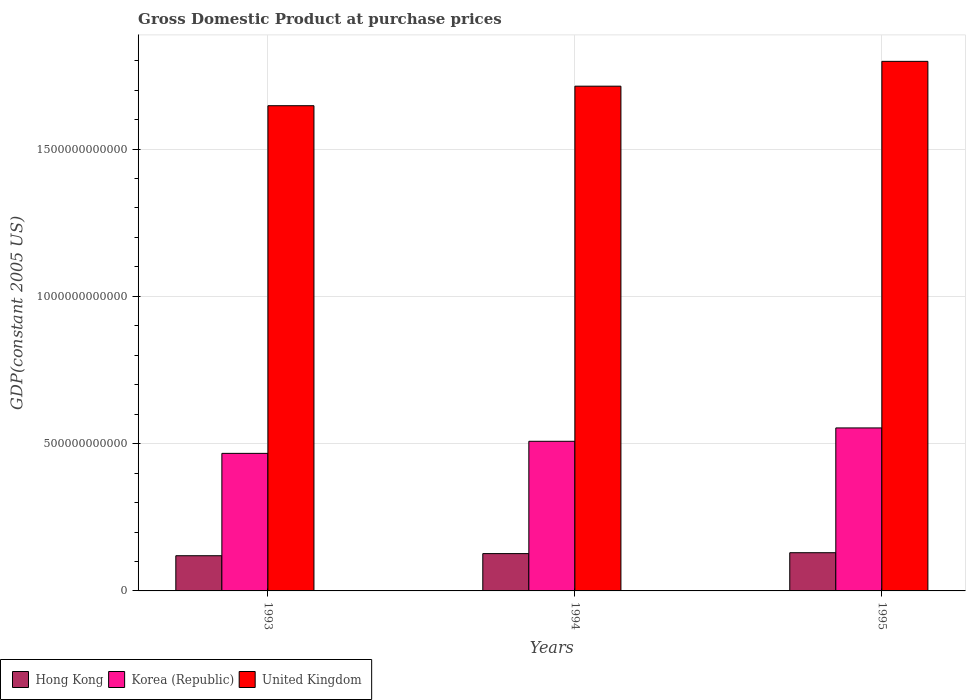How many different coloured bars are there?
Ensure brevity in your answer.  3. How many bars are there on the 1st tick from the left?
Ensure brevity in your answer.  3. How many bars are there on the 1st tick from the right?
Give a very brief answer. 3. What is the label of the 3rd group of bars from the left?
Provide a short and direct response. 1995. What is the GDP at purchase prices in United Kingdom in 1993?
Your answer should be compact. 1.65e+12. Across all years, what is the maximum GDP at purchase prices in United Kingdom?
Give a very brief answer. 1.80e+12. Across all years, what is the minimum GDP at purchase prices in United Kingdom?
Offer a very short reply. 1.65e+12. What is the total GDP at purchase prices in United Kingdom in the graph?
Your answer should be compact. 5.16e+12. What is the difference between the GDP at purchase prices in United Kingdom in 1994 and that in 1995?
Your answer should be compact. -8.43e+1. What is the difference between the GDP at purchase prices in United Kingdom in 1993 and the GDP at purchase prices in Korea (Republic) in 1995?
Offer a terse response. 1.09e+12. What is the average GDP at purchase prices in Hong Kong per year?
Provide a succinct answer. 1.25e+11. In the year 1995, what is the difference between the GDP at purchase prices in Hong Kong and GDP at purchase prices in Korea (Republic)?
Ensure brevity in your answer.  -4.24e+11. What is the ratio of the GDP at purchase prices in Korea (Republic) in 1994 to that in 1995?
Your answer should be very brief. 0.92. Is the GDP at purchase prices in Korea (Republic) in 1994 less than that in 1995?
Make the answer very short. Yes. What is the difference between the highest and the second highest GDP at purchase prices in United Kingdom?
Make the answer very short. 8.43e+1. What is the difference between the highest and the lowest GDP at purchase prices in Hong Kong?
Offer a very short reply. 1.02e+1. What does the 2nd bar from the left in 1995 represents?
Your answer should be compact. Korea (Republic). Is it the case that in every year, the sum of the GDP at purchase prices in United Kingdom and GDP at purchase prices in Hong Kong is greater than the GDP at purchase prices in Korea (Republic)?
Give a very brief answer. Yes. How many bars are there?
Give a very brief answer. 9. How many years are there in the graph?
Your answer should be very brief. 3. What is the difference between two consecutive major ticks on the Y-axis?
Your answer should be compact. 5.00e+11. Does the graph contain any zero values?
Give a very brief answer. No. Does the graph contain grids?
Offer a very short reply. Yes. Where does the legend appear in the graph?
Your answer should be compact. Bottom left. How many legend labels are there?
Provide a short and direct response. 3. How are the legend labels stacked?
Provide a succinct answer. Horizontal. What is the title of the graph?
Your answer should be very brief. Gross Domestic Product at purchase prices. Does "Cameroon" appear as one of the legend labels in the graph?
Offer a very short reply. No. What is the label or title of the Y-axis?
Your answer should be very brief. GDP(constant 2005 US). What is the GDP(constant 2005 US) in Hong Kong in 1993?
Make the answer very short. 1.20e+11. What is the GDP(constant 2005 US) in Korea (Republic) in 1993?
Make the answer very short. 4.67e+11. What is the GDP(constant 2005 US) in United Kingdom in 1993?
Your response must be concise. 1.65e+12. What is the GDP(constant 2005 US) in Hong Kong in 1994?
Offer a very short reply. 1.27e+11. What is the GDP(constant 2005 US) of Korea (Republic) in 1994?
Offer a very short reply. 5.08e+11. What is the GDP(constant 2005 US) in United Kingdom in 1994?
Your answer should be compact. 1.71e+12. What is the GDP(constant 2005 US) of Hong Kong in 1995?
Your answer should be compact. 1.30e+11. What is the GDP(constant 2005 US) in Korea (Republic) in 1995?
Give a very brief answer. 5.53e+11. What is the GDP(constant 2005 US) in United Kingdom in 1995?
Provide a succinct answer. 1.80e+12. Across all years, what is the maximum GDP(constant 2005 US) in Hong Kong?
Keep it short and to the point. 1.30e+11. Across all years, what is the maximum GDP(constant 2005 US) in Korea (Republic)?
Provide a succinct answer. 5.53e+11. Across all years, what is the maximum GDP(constant 2005 US) of United Kingdom?
Offer a very short reply. 1.80e+12. Across all years, what is the minimum GDP(constant 2005 US) in Hong Kong?
Make the answer very short. 1.20e+11. Across all years, what is the minimum GDP(constant 2005 US) of Korea (Republic)?
Ensure brevity in your answer.  4.67e+11. Across all years, what is the minimum GDP(constant 2005 US) of United Kingdom?
Offer a very short reply. 1.65e+12. What is the total GDP(constant 2005 US) of Hong Kong in the graph?
Make the answer very short. 3.76e+11. What is the total GDP(constant 2005 US) of Korea (Republic) in the graph?
Provide a succinct answer. 1.53e+12. What is the total GDP(constant 2005 US) of United Kingdom in the graph?
Ensure brevity in your answer.  5.16e+12. What is the difference between the GDP(constant 2005 US) in Hong Kong in 1993 and that in 1994?
Provide a succinct answer. -7.21e+09. What is the difference between the GDP(constant 2005 US) of Korea (Republic) in 1993 and that in 1994?
Your response must be concise. -4.10e+1. What is the difference between the GDP(constant 2005 US) in United Kingdom in 1993 and that in 1994?
Make the answer very short. -6.63e+1. What is the difference between the GDP(constant 2005 US) in Hong Kong in 1993 and that in 1995?
Your response must be concise. -1.02e+1. What is the difference between the GDP(constant 2005 US) of Korea (Republic) in 1993 and that in 1995?
Your answer should be compact. -8.63e+1. What is the difference between the GDP(constant 2005 US) in United Kingdom in 1993 and that in 1995?
Provide a short and direct response. -1.51e+11. What is the difference between the GDP(constant 2005 US) of Hong Kong in 1994 and that in 1995?
Offer a very short reply. -3.01e+09. What is the difference between the GDP(constant 2005 US) of Korea (Republic) in 1994 and that in 1995?
Make the answer very short. -4.54e+1. What is the difference between the GDP(constant 2005 US) in United Kingdom in 1994 and that in 1995?
Your answer should be very brief. -8.43e+1. What is the difference between the GDP(constant 2005 US) in Hong Kong in 1993 and the GDP(constant 2005 US) in Korea (Republic) in 1994?
Make the answer very short. -3.88e+11. What is the difference between the GDP(constant 2005 US) in Hong Kong in 1993 and the GDP(constant 2005 US) in United Kingdom in 1994?
Your answer should be compact. -1.59e+12. What is the difference between the GDP(constant 2005 US) in Korea (Republic) in 1993 and the GDP(constant 2005 US) in United Kingdom in 1994?
Provide a succinct answer. -1.25e+12. What is the difference between the GDP(constant 2005 US) of Hong Kong in 1993 and the GDP(constant 2005 US) of Korea (Republic) in 1995?
Offer a very short reply. -4.34e+11. What is the difference between the GDP(constant 2005 US) in Hong Kong in 1993 and the GDP(constant 2005 US) in United Kingdom in 1995?
Provide a short and direct response. -1.68e+12. What is the difference between the GDP(constant 2005 US) of Korea (Republic) in 1993 and the GDP(constant 2005 US) of United Kingdom in 1995?
Offer a very short reply. -1.33e+12. What is the difference between the GDP(constant 2005 US) of Hong Kong in 1994 and the GDP(constant 2005 US) of Korea (Republic) in 1995?
Provide a short and direct response. -4.27e+11. What is the difference between the GDP(constant 2005 US) in Hong Kong in 1994 and the GDP(constant 2005 US) in United Kingdom in 1995?
Offer a terse response. -1.67e+12. What is the difference between the GDP(constant 2005 US) in Korea (Republic) in 1994 and the GDP(constant 2005 US) in United Kingdom in 1995?
Give a very brief answer. -1.29e+12. What is the average GDP(constant 2005 US) of Hong Kong per year?
Provide a short and direct response. 1.25e+11. What is the average GDP(constant 2005 US) in Korea (Republic) per year?
Ensure brevity in your answer.  5.09e+11. What is the average GDP(constant 2005 US) of United Kingdom per year?
Make the answer very short. 1.72e+12. In the year 1993, what is the difference between the GDP(constant 2005 US) in Hong Kong and GDP(constant 2005 US) in Korea (Republic)?
Provide a succinct answer. -3.47e+11. In the year 1993, what is the difference between the GDP(constant 2005 US) in Hong Kong and GDP(constant 2005 US) in United Kingdom?
Provide a succinct answer. -1.53e+12. In the year 1993, what is the difference between the GDP(constant 2005 US) in Korea (Republic) and GDP(constant 2005 US) in United Kingdom?
Your response must be concise. -1.18e+12. In the year 1994, what is the difference between the GDP(constant 2005 US) of Hong Kong and GDP(constant 2005 US) of Korea (Republic)?
Make the answer very short. -3.81e+11. In the year 1994, what is the difference between the GDP(constant 2005 US) of Hong Kong and GDP(constant 2005 US) of United Kingdom?
Ensure brevity in your answer.  -1.59e+12. In the year 1994, what is the difference between the GDP(constant 2005 US) in Korea (Republic) and GDP(constant 2005 US) in United Kingdom?
Provide a short and direct response. -1.21e+12. In the year 1995, what is the difference between the GDP(constant 2005 US) in Hong Kong and GDP(constant 2005 US) in Korea (Republic)?
Provide a short and direct response. -4.24e+11. In the year 1995, what is the difference between the GDP(constant 2005 US) of Hong Kong and GDP(constant 2005 US) of United Kingdom?
Provide a succinct answer. -1.67e+12. In the year 1995, what is the difference between the GDP(constant 2005 US) in Korea (Republic) and GDP(constant 2005 US) in United Kingdom?
Your answer should be very brief. -1.24e+12. What is the ratio of the GDP(constant 2005 US) in Hong Kong in 1993 to that in 1994?
Your answer should be compact. 0.94. What is the ratio of the GDP(constant 2005 US) in Korea (Republic) in 1993 to that in 1994?
Your response must be concise. 0.92. What is the ratio of the GDP(constant 2005 US) of United Kingdom in 1993 to that in 1994?
Offer a very short reply. 0.96. What is the ratio of the GDP(constant 2005 US) in Hong Kong in 1993 to that in 1995?
Make the answer very short. 0.92. What is the ratio of the GDP(constant 2005 US) of Korea (Republic) in 1993 to that in 1995?
Provide a short and direct response. 0.84. What is the ratio of the GDP(constant 2005 US) of United Kingdom in 1993 to that in 1995?
Your answer should be compact. 0.92. What is the ratio of the GDP(constant 2005 US) of Hong Kong in 1994 to that in 1995?
Keep it short and to the point. 0.98. What is the ratio of the GDP(constant 2005 US) in Korea (Republic) in 1994 to that in 1995?
Your response must be concise. 0.92. What is the ratio of the GDP(constant 2005 US) in United Kingdom in 1994 to that in 1995?
Offer a terse response. 0.95. What is the difference between the highest and the second highest GDP(constant 2005 US) of Hong Kong?
Ensure brevity in your answer.  3.01e+09. What is the difference between the highest and the second highest GDP(constant 2005 US) of Korea (Republic)?
Your answer should be compact. 4.54e+1. What is the difference between the highest and the second highest GDP(constant 2005 US) in United Kingdom?
Offer a terse response. 8.43e+1. What is the difference between the highest and the lowest GDP(constant 2005 US) of Hong Kong?
Your answer should be very brief. 1.02e+1. What is the difference between the highest and the lowest GDP(constant 2005 US) of Korea (Republic)?
Provide a succinct answer. 8.63e+1. What is the difference between the highest and the lowest GDP(constant 2005 US) of United Kingdom?
Your response must be concise. 1.51e+11. 